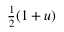<formula> <loc_0><loc_0><loc_500><loc_500>\frac { 1 } { 2 } ( 1 + u )</formula> 